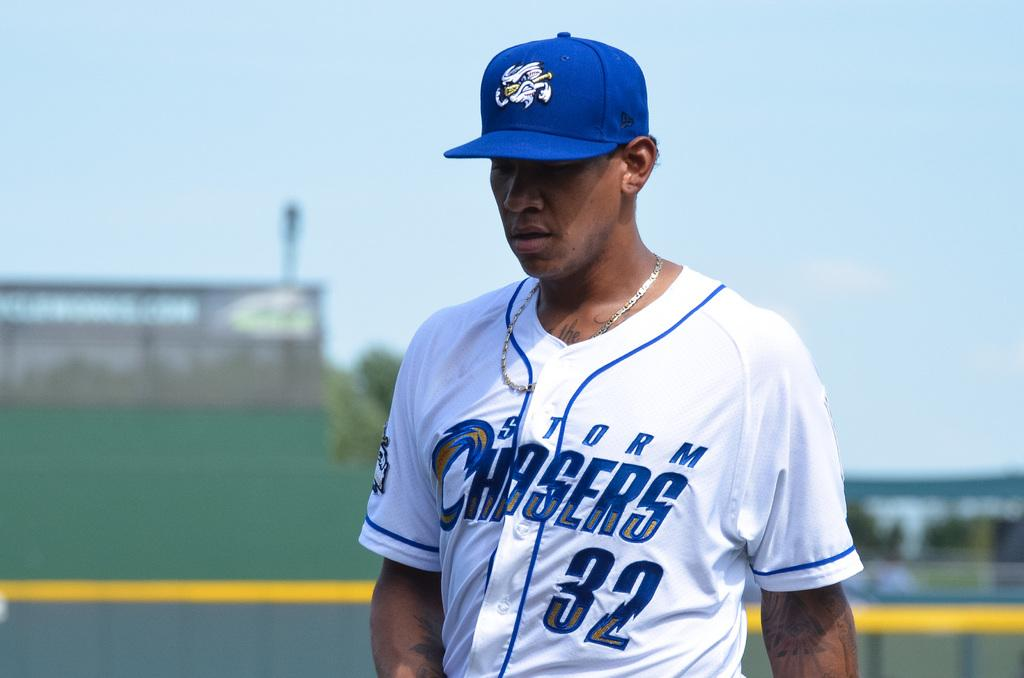<image>
Provide a brief description of the given image. A baseball player wearing a blue cap and a white top with Storm Chasers and the number 32 on it walks on the field. 